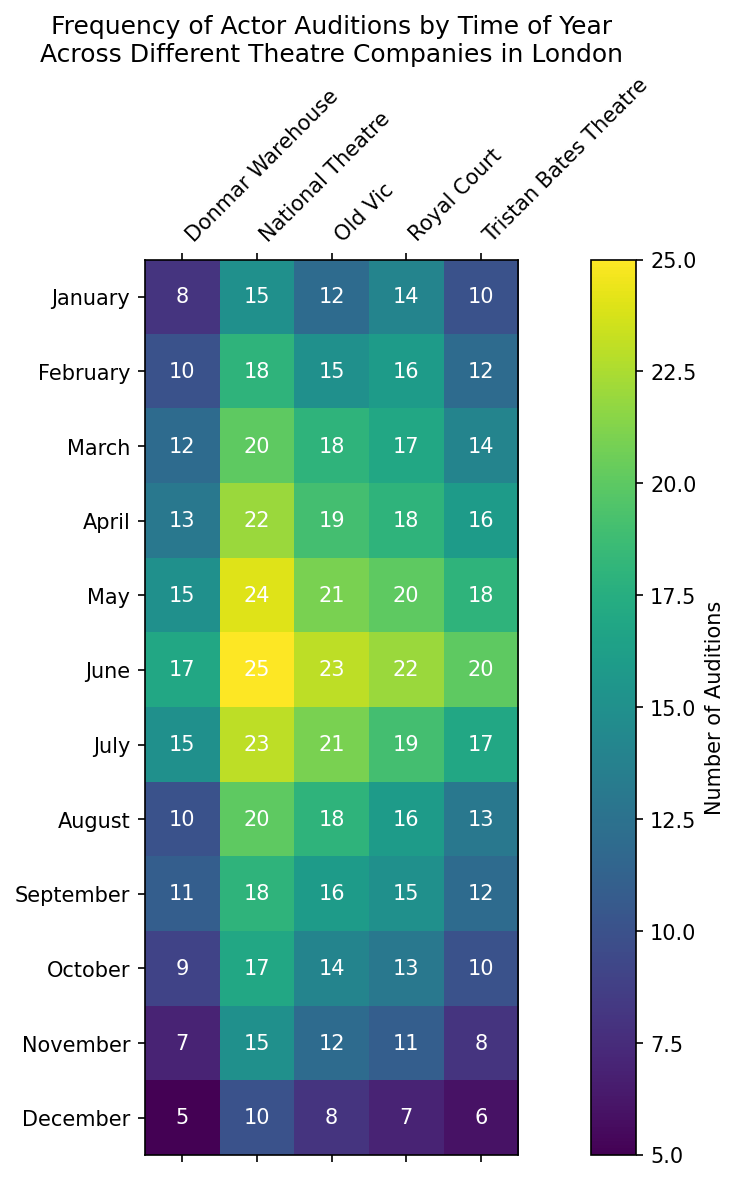What is the total number of auditions conducted by the National Theatre in the first quarter (January to March)? Sum the number of auditions conducted in January, February, and March by the National Theatre. January: 15, February: 18, March: 20. Total = 15 + 18 + 20 = 53
Answer: 53 Which theatre company had the least number of auditions in December? Look for the smallest number of auditions in December across all theatre companies. The values are: National Theatre (10), Tristan Bates Theatre (6), Old Vic (8), Donmar Warehouse (5), Royal Court (7). The smallest value is 5 by Donmar Warehouse
Answer: Donmar Warehouse In which month did Tristan Bates Theatre have the highest number of auditions? Identify the maximum number of auditions for Tristan Bates Theatre across all months. The values are: January (10), February (12), March (14), April (16), May (18), June (20), July (17), August (13), September (12), October (10), November (8), December (6). The highest value is 20 in June
Answer: June Which month exhibited the highest total number of auditions across all theatre companies? Sum the number of auditions for each month across all theatres and find the maximum. January: (15+10+12+8+14)=59, February: (18+12+15+10+16)=71, March: (20+14+18+12+17)=81, April: (22+16+19+13+18)=88, May: (24+18+21+15+20)=98, June: (25+20+23+17+22)=107, July: (23+17+21+15+19)=95, August: (20+13+18+10+16)=77, September: (18+12+16+11+15)=72, October: (17+10+14+9+13)=63, November: (15+8+12+7+11)=53, December: (10+6+8+5+7)=36. The highest total is 107 in June
Answer: June How does the total number of auditions at Old Vic in the second quarter (April to June) compare to that in the third quarter (July to September)? Calculate the sum of auditions in April, May, and June for the second quarter, and in July, August, and September for the third quarter at Old Vic. Second quarter: April (19) + May (21) + June (23) = 63; Third quarter: July (21) + August (18) + September (16) = 55. Compare the totals: 63 is greater than 55
Answer: Second quarter has more What trend can you observe in the number of auditions at Tristan Bates Theatre from January to December? Look at the number of auditions for each month at Tristan Bates Theatre from the start to the end of the year and identify the pattern. The values are: January (10), February (12), March (14), April (16), May (18), June (20), July (17), August (13), September (12), October (10), November (8), December (6). There is a general increase until June, followed by a decline till December
Answer: Increase till June, decline till December How many more auditions were held at the Royal Court in October compared to December? Subtract the number of auditions in December from the number in October at the Royal Court. October: 13, December: 7. Difference = 13 - 7 = 6
Answer: 6 Which theatre company held the greatest number of auditions in May? Identify the highest number of auditions in May across all theatre companies. The values are: National Theatre (24), Tristan Bates Theatre (18), Old Vic (21), Donmar Warehouse (15), Royal Court (20). The highest value is 24 by National Theatre
Answer: National Theatre 